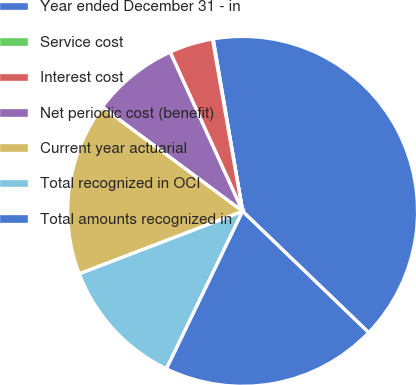Convert chart. <chart><loc_0><loc_0><loc_500><loc_500><pie_chart><fcel>Year ended December 31 - in<fcel>Service cost<fcel>Interest cost<fcel>Net periodic cost (benefit)<fcel>Current year actuarial<fcel>Total recognized in OCI<fcel>Total amounts recognized in<nl><fcel>39.89%<fcel>0.06%<fcel>4.04%<fcel>8.03%<fcel>15.99%<fcel>12.01%<fcel>19.98%<nl></chart> 